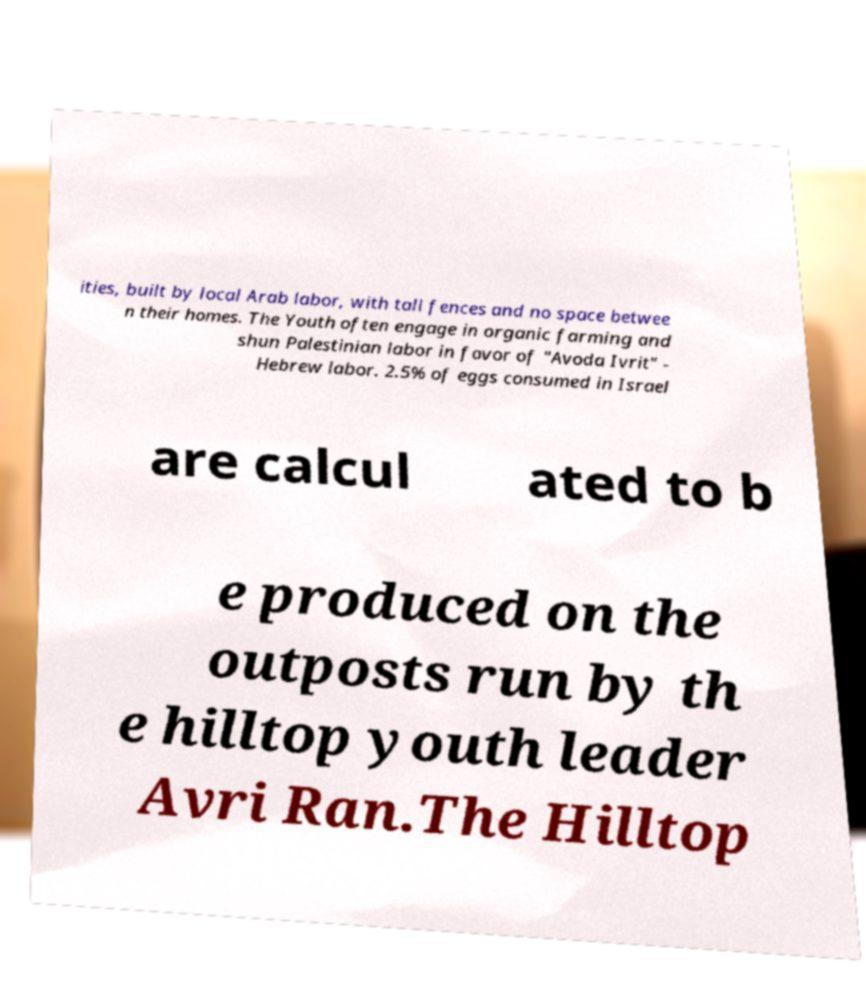What messages or text are displayed in this image? I need them in a readable, typed format. ities, built by local Arab labor, with tall fences and no space betwee n their homes. The Youth often engage in organic farming and shun Palestinian labor in favor of "Avoda Ivrit" - Hebrew labor. 2.5% of eggs consumed in Israel are calcul ated to b e produced on the outposts run by th e hilltop youth leader Avri Ran.The Hilltop 